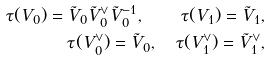<formula> <loc_0><loc_0><loc_500><loc_500>\tau ( V _ { 0 } ) = \tilde { V } _ { 0 } \tilde { V } _ { 0 } ^ { \vee } \tilde { V } _ { 0 } ^ { - 1 } , \quad \tau ( V _ { 1 } ) = \tilde { V } _ { 1 } , \\ \tau ( V ^ { \vee } _ { 0 } ) = \tilde { V } _ { 0 } , \quad \tau ( V ^ { \vee } _ { 1 } ) = \tilde { V } _ { 1 } ^ { \vee } ,</formula> 